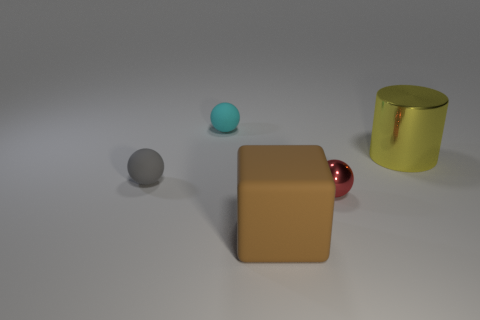Can you speculate on the size of these objects? Are they small like tabletop objects or larger like furniture? Judging by the composition and the shadows, these objects could be small enough to fit on a tabletop. They resemble decorative items or design elements you might find in a modern interior setting. The scale is slightly ambiguous without a reference object for absolute size, but the texture and lighting suggest they are not full-sized furniture. 